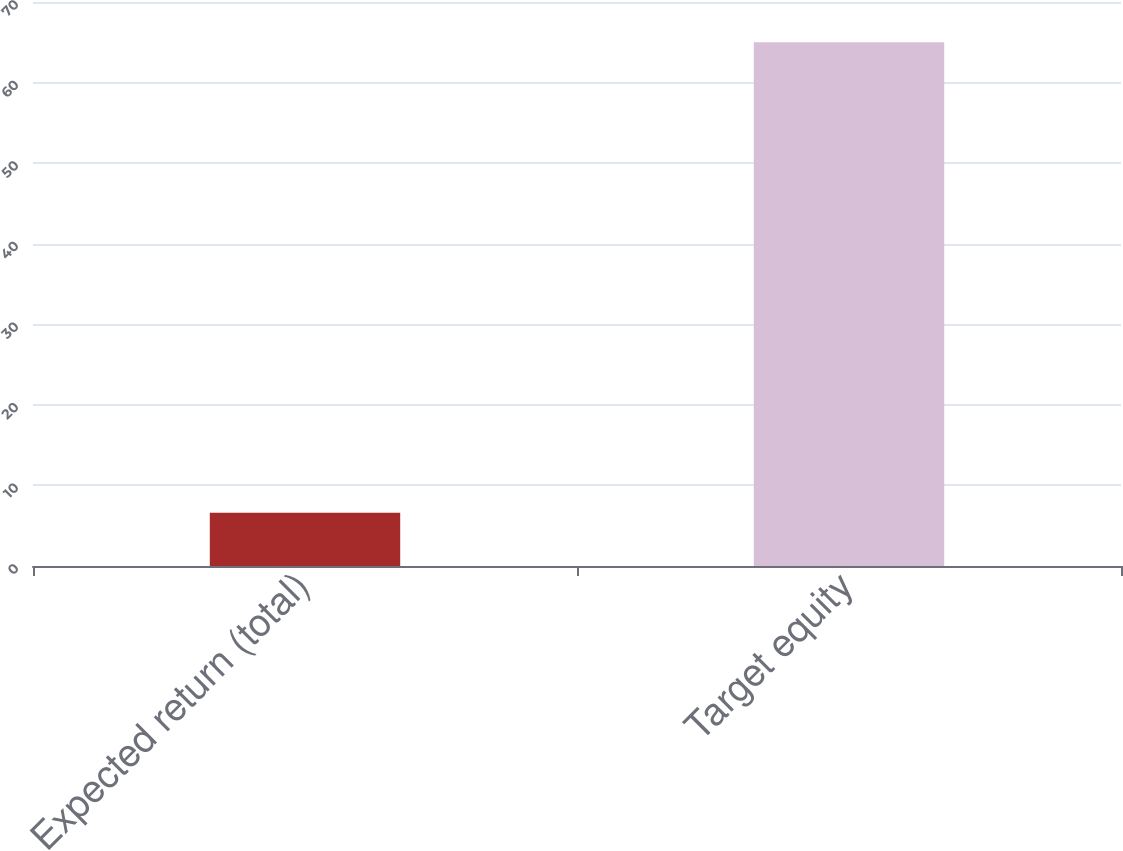Convert chart. <chart><loc_0><loc_0><loc_500><loc_500><bar_chart><fcel>Expected return (total)<fcel>Target equity<nl><fcel>6.6<fcel>65<nl></chart> 